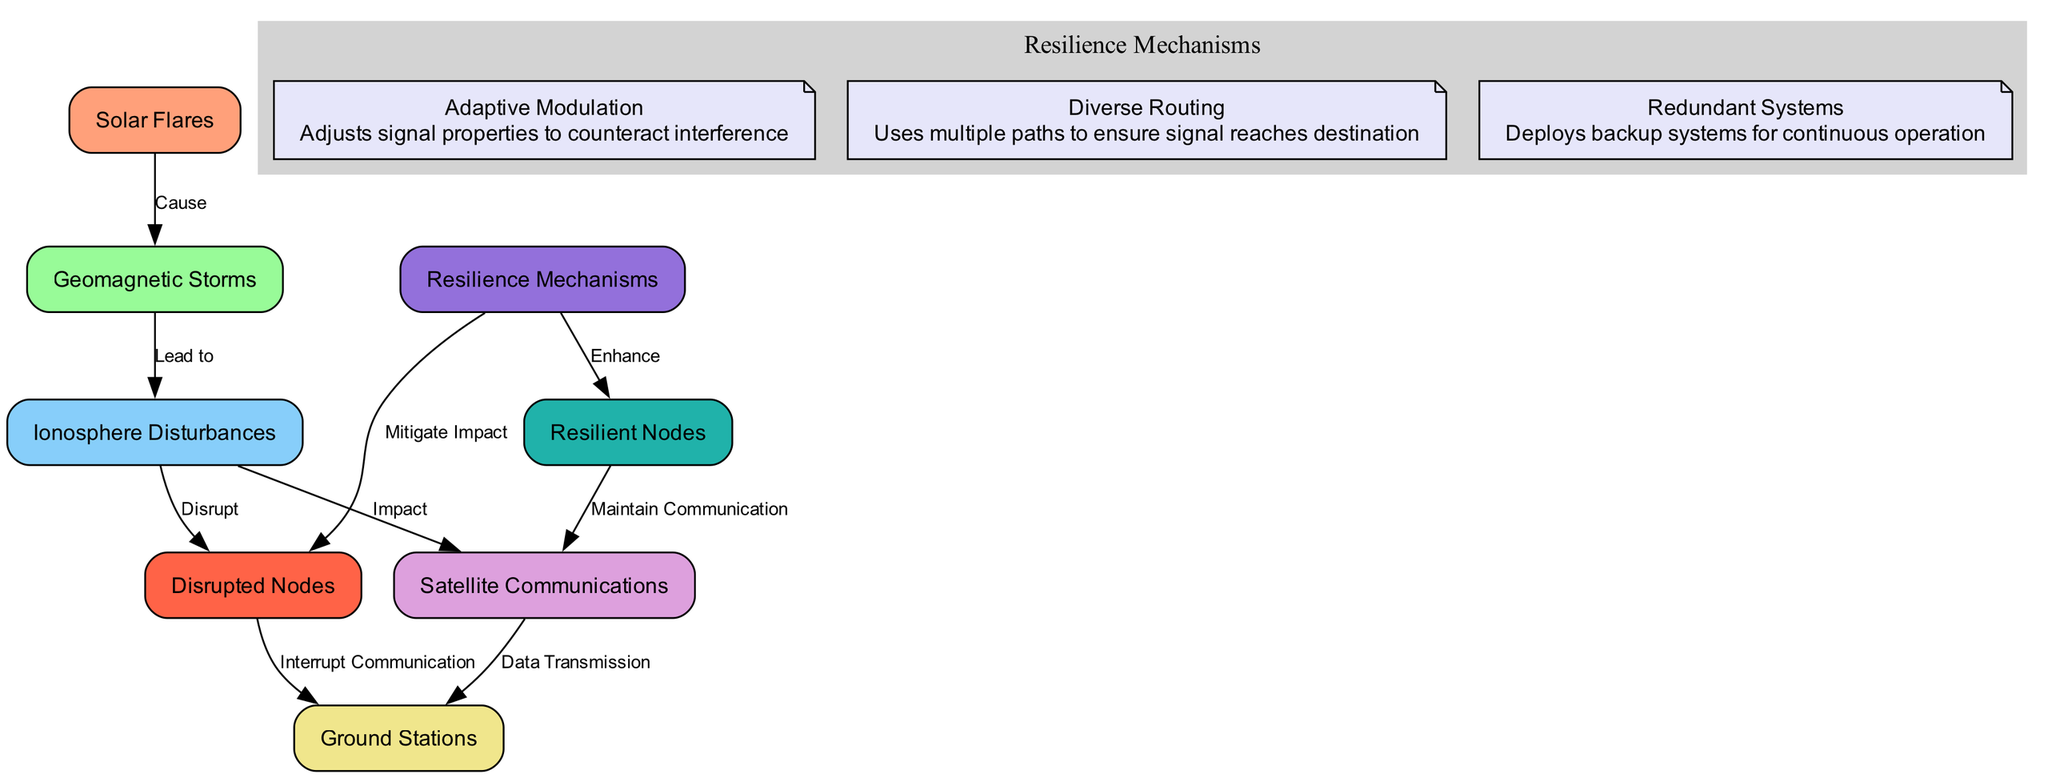What are the nodes in this diagram? The nodes in the diagram include solar flares, geomagnetic storms, ionosphere disturbances, satellite communications, ground stations, resilient nodes, disrupted nodes, and resilience mechanisms.
Answer: solar flares, geomagnetic storms, ionosphere disturbances, satellite communications, ground stations, resilient nodes, disrupted nodes, resilience mechanisms How many edges are in the diagram? To find the number of edges, we count each directed relationship shown between nodes. There are eight edges connecting different nodes logically in the diagram.
Answer: 8 What is the relationship between solar flares and geomagnetic storms? The relationship shown is that solar flares cause geomagnetic storms, indicated by a directed edge labeled "Cause."
Answer: Cause Which node is affected by ionosphere disturbances? The node impacted by ionosphere disturbances is satellite communications, as shown by the directed edge labeled "Impact."
Answer: satellite communications What enhances resilient nodes? Resilience mechanisms enhance the resilient nodes, indicated by the directed edge stating "Enhance."
Answer: Resilience Mechanisms What do disrupted nodes interrupt? The disrupted nodes interrupt communication to ground stations, as indicated by the directed edge labeled "Interrupt Communication."
Answer: Communication What is the role of diverse routing as a resilience mechanism? Diverse routing allows for using multiple paths to ensure signal reaches its destination, thus enhancing the reliability of communication.
Answer: Uses multiple paths What leads to ionosphere disturbances? Geomagnetic storms lead to ionosphere disturbances, as depicted by the directed edge labeled "Lead to."
Answer: Geomagnetic Storms Which node maintains communication? Resilient nodes are responsible for maintaining communication, as indicated by the directed edge labeled "Maintain Communication."
Answer: resilient nodes 